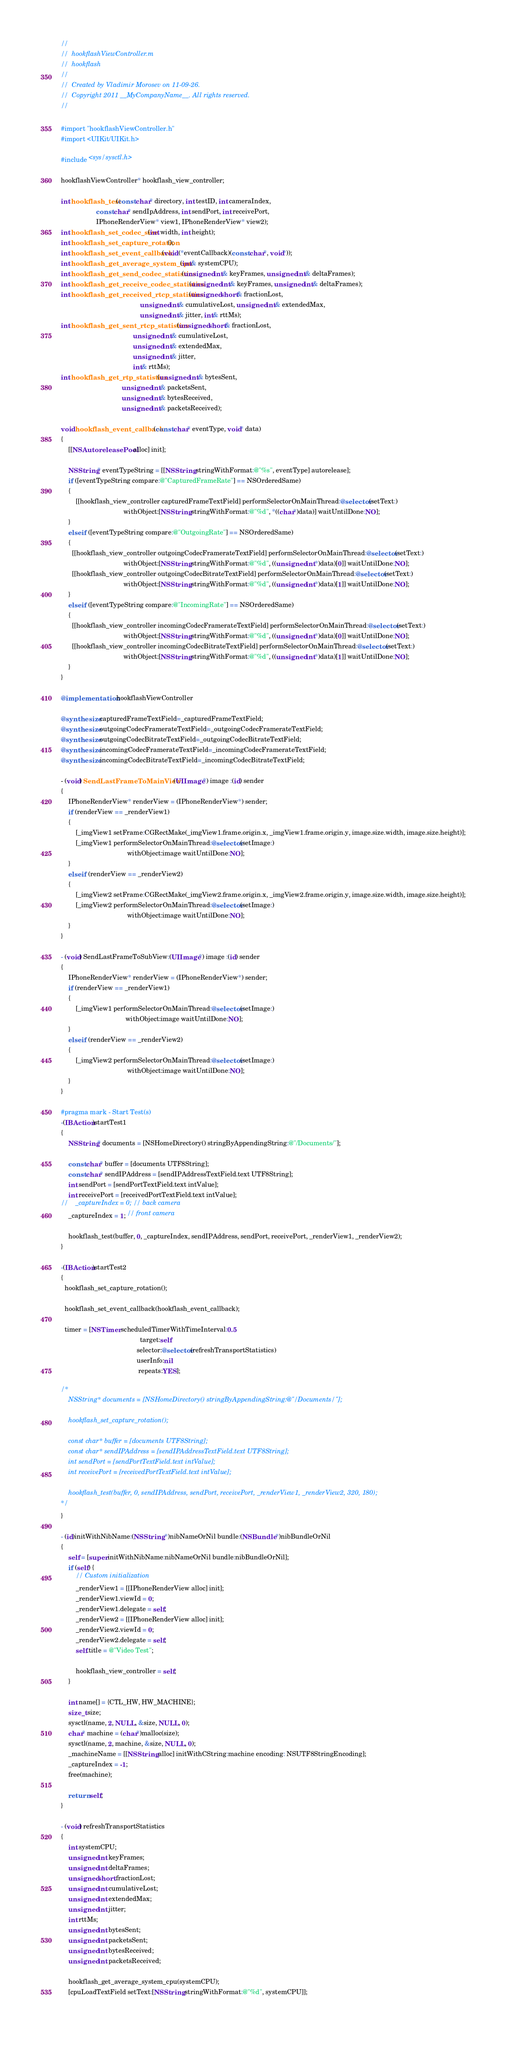Convert code to text. <code><loc_0><loc_0><loc_500><loc_500><_ObjectiveC_>//
//  hookflashViewController.m
//  hookflash
//
//  Created by Vladimir Morosev on 11-09-26.
//  Copyright 2011 __MyCompanyName__. All rights reserved.
//

#import "hookflashViewController.h"
#import <UIKit/UIKit.h>

#include <sys/sysctl.h>

hookflashViewController* hookflash_view_controller;

int hookflash_test(const char* directory, int testID, int cameraIndex, 
                   const char* sendIpAddress, int sendPort, int receivePort,
                   IPhoneRenderView* view1, IPhoneRenderView* view2);
int hookflash_set_codec_size(int width, int height);
int hookflash_set_capture_rotation();
int hookflash_set_event_callback(void (*eventCallback)(const char*, void*));
int hookflash_get_average_system_cpu(int& systemCPU);
int hookflash_get_send_codec_statistics(unsigned int& keyFrames, unsigned int& deltaFrames);
int hookflash_get_receive_codec_statistics(unsigned int& keyFrames, unsigned int& deltaFrames);
int hookflash_get_received_rtcp_statistics(unsigned short& fractionLost,
                                           unsigned int& cumulativeLost, unsigned int& extendedMax,
                                           unsigned int& jitter, int& rttMs);
int hookflash_get_sent_rtcp_statistics(unsigned short& fractionLost,
                                       unsigned int& cumulativeLost,
                                       unsigned int& extendedMax,
                                       unsigned int& jitter,
                                       int& rttMs);
int hookflash_get_rtp_statistics(unsigned int& bytesSent,
                                 unsigned int& packetsSent,
                                 unsigned int& bytesReceived,
                                 unsigned int& packetsReceived);

void hookflash_event_callback(const char* eventType, void* data)
{
    [[NSAutoreleasePool alloc] init];
    
    NSString* eventTypeString = [[NSString stringWithFormat:@"%s", eventType] autorelease];
    if ([eventTypeString compare:@"CapturedFrameRate"] == NSOrderedSame)
    {
        [[hookflash_view_controller capturedFrameTextField] performSelectorOnMainThread:@selector(setText:)
                                  withObject:[NSString stringWithFormat:@"%d", *((char*)data)] waitUntilDone:NO];
    }
    else if ([eventTypeString compare:@"OutgoingRate"] == NSOrderedSame)
    {
      [[hookflash_view_controller outgoingCodecFramerateTextField] performSelectorOnMainThread:@selector(setText:)
                                  withObject:[NSString stringWithFormat:@"%d", ((unsigned int*)data)[0]] waitUntilDone:NO];
      [[hookflash_view_controller outgoingCodecBitrateTextField] performSelectorOnMainThread:@selector(setText:)
                                  withObject:[NSString stringWithFormat:@"%d", ((unsigned int*)data)[1]] waitUntilDone:NO];
    }
    else if ([eventTypeString compare:@"IncomingRate"] == NSOrderedSame)
    {
      [[hookflash_view_controller incomingCodecFramerateTextField] performSelectorOnMainThread:@selector(setText:)
                                  withObject:[NSString stringWithFormat:@"%d", ((unsigned int*)data)[0]] waitUntilDone:NO];
      [[hookflash_view_controller incomingCodecBitrateTextField] performSelectorOnMainThread:@selector(setText:)
                                  withObject:[NSString stringWithFormat:@"%d", ((unsigned int*)data)[1]] waitUntilDone:NO];
    }
}

@implementation hookflashViewController

@synthesize capturedFrameTextField=_capturedFrameTextField;
@synthesize outgoingCodecFramerateTextField=_outgoingCodecFramerateTextField;
@synthesize outgoingCodecBitrateTextField=_outgoingCodecBitrateTextField;
@synthesize incomingCodecFramerateTextField=_incomingCodecFramerateTextField;
@synthesize incomingCodecBitrateTextField=_incomingCodecBitrateTextField;

- (void) SendLastFrameToMainView:(UIImage*) image :(id) sender
{
    IPhoneRenderView* renderView = (IPhoneRenderView*) sender;
    if (renderView == _renderView1)
    {
        [_imgView1 setFrame:CGRectMake(_imgView1.frame.origin.x, _imgView1.frame.origin.y, image.size.width, image.size.height)];
        [_imgView1 performSelectorOnMainThread:@selector(setImage:)
                                    withObject:image waitUntilDone:NO];
    }
    else if (renderView == _renderView2)
    {
        [_imgView2 setFrame:CGRectMake(_imgView2.frame.origin.x, _imgView2.frame.origin.y, image.size.width, image.size.height)];
        [_imgView2 performSelectorOnMainThread:@selector(setImage:)
                                    withObject:image waitUntilDone:NO];
    }
}

- (void) SendLastFrameToSubView:(UIImage*) image :(id) sender
{
    IPhoneRenderView* renderView = (IPhoneRenderView*) sender;
    if (renderView == _renderView1)
    {
        [_imgView1 performSelectorOnMainThread:@selector(setImage:)
                                   withObject:image waitUntilDone:NO];
    }
    else if (renderView == _renderView2)
    {
        [_imgView2 performSelectorOnMainThread:@selector(setImage:)
                                    withObject:image waitUntilDone:NO];
    }
}

#pragma mark - Start Test(s)
-(IBAction)startTest1
{    
    NSString* documents = [NSHomeDirectory() stringByAppendingString:@"/Documents/"];
    
    const char* buffer = [documents UTF8String];
    const char* sendIPAddress = [sendIPAddressTextField.text UTF8String];
    int sendPort = [sendPortTextField.text intValue];
    int receivePort = [receivedPortTextField.text intValue];
//    _captureIndex = 0; // back camera
    _captureIndex = 1; // front camera

    hookflash_test(buffer, 0, _captureIndex, sendIPAddress, sendPort, receivePort, _renderView1, _renderView2);
}

-(IBAction)startTest2
{    
  hookflash_set_capture_rotation();
  
  hookflash_set_event_callback(hookflash_event_callback);
  
  timer = [NSTimer scheduledTimerWithTimeInterval:0.5
                                           target:self
                                         selector:@selector(refreshTransportStatistics)
                                         userInfo:nil
                                          repeats:YES];

/*
    NSString* documents = [NSHomeDirectory() stringByAppendingString:@"/Documents/"];
  
    hookflash_set_capture_rotation();

    const char* buffer = [documents UTF8String];
    const char* sendIPAddress = [sendIPAddressTextField.text UTF8String];
    int sendPort = [sendPortTextField.text intValue];
    int receivePort = [receivedPortTextField.text intValue];
    
    hookflash_test(buffer, 0, sendIPAddress, sendPort, receivePort, _renderView1, _renderView2, 320, 180);
*/
}

- (id)initWithNibName:(NSString *)nibNameOrNil bundle:(NSBundle *)nibBundleOrNil
{
    self = [super initWithNibName:nibNameOrNil bundle:nibBundleOrNil];
    if (self) {
        // Custom initialization
        _renderView1 = [[IPhoneRenderView alloc] init];
        _renderView1.viewId = 0;
        _renderView1.delegate = self;
        _renderView2 = [[IPhoneRenderView alloc] init];
        _renderView2.viewId = 0;
        _renderView2.delegate = self;
        self.title = @"Video Test";
      
        hookflash_view_controller = self;
    }

    int name[] = {CTL_HW, HW_MACHINE};
    size_t size;
    sysctl(name, 2, NULL, &size, NULL, 0);
    char* machine = (char*)malloc(size);
    sysctl(name, 2, machine, &size, NULL, 0);
    _machineName = [[NSString alloc] initWithCString:machine encoding: NSUTF8StringEncoding];
    _captureIndex = -1;
    free(machine);

    return self;
}

- (void) refreshTransportStatistics
{
    int systemCPU;
    unsigned int keyFrames;
    unsigned int deltaFrames;
    unsigned short fractionLost;
    unsigned int cumulativeLost; 
    unsigned int extendedMax;
    unsigned int jitter; 
    int rttMs;
    unsigned int bytesSent;
    unsigned int packetsSent;
    unsigned int bytesReceived;
    unsigned int packetsReceived;
  
    hookflash_get_average_system_cpu(systemCPU);
    [cpuLoadTextField setText:[NSString stringWithFormat:@"%d", systemCPU]];
  </code> 